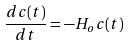<formula> <loc_0><loc_0><loc_500><loc_500>\frac { d c ( t ) } { d t } = - H _ { o } c ( t )</formula> 